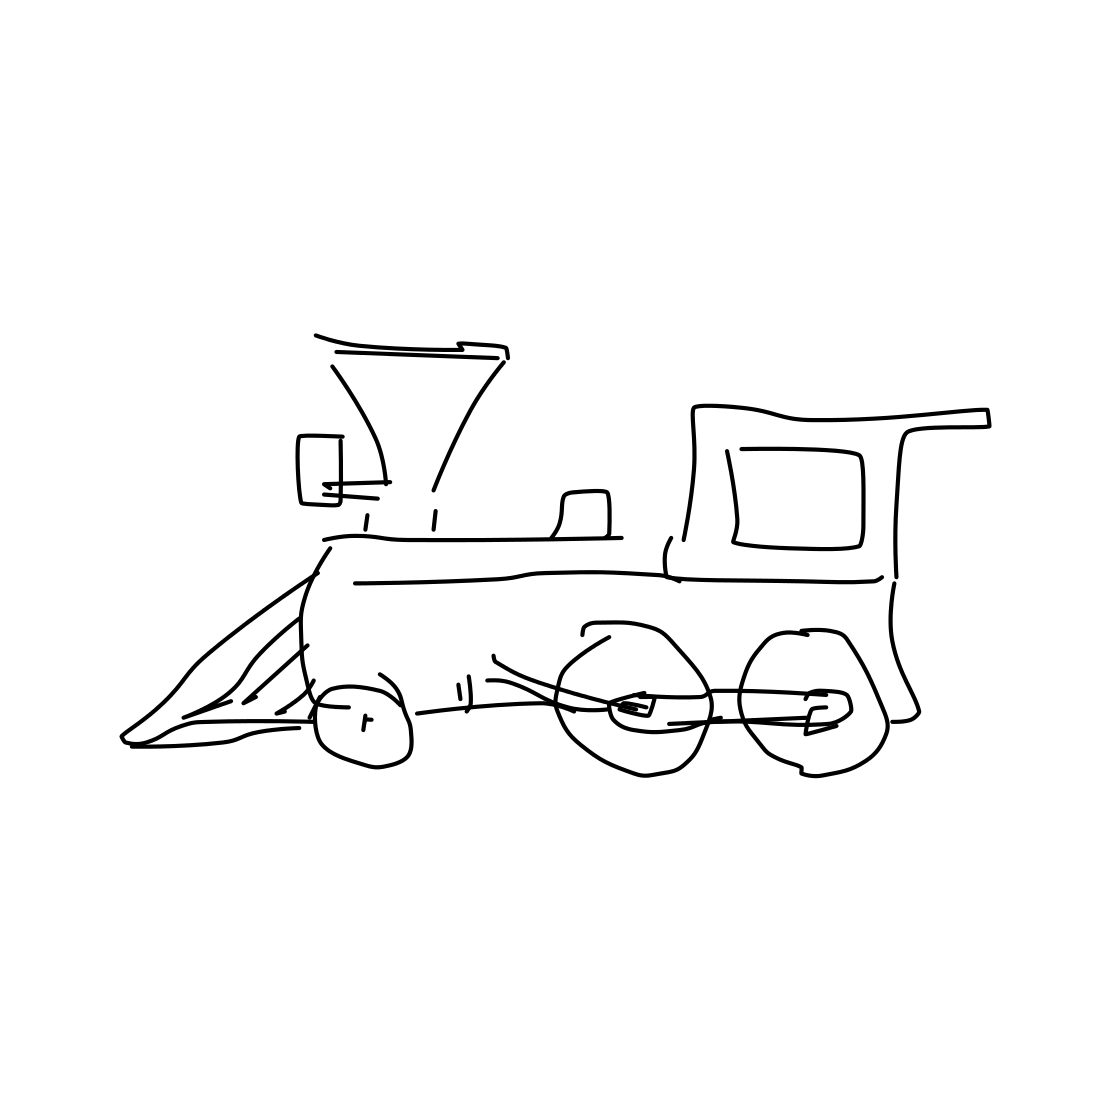Could you tell me what the front part of the train, with the triangular shape, is used for? Certainly! That triangular part is known as a cowcatcher or pilot. It's designed to deflect obstacles on the tracks, like livestock or debris, to prevent them from getting under the wheels, which could lead to derailment. 